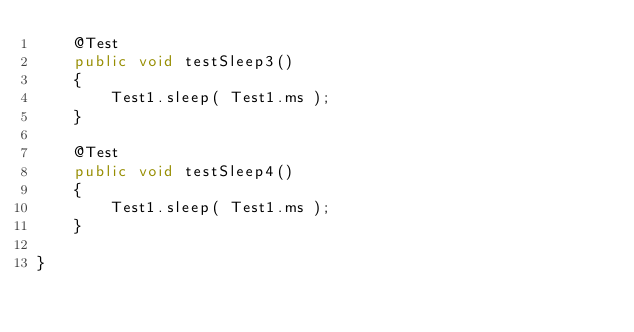<code> <loc_0><loc_0><loc_500><loc_500><_Java_>    @Test
    public void testSleep3()
    {
        Test1.sleep( Test1.ms );
    }

    @Test
    public void testSleep4()
    {
        Test1.sleep( Test1.ms );
    }

}</code> 